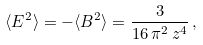<formula> <loc_0><loc_0><loc_500><loc_500>\langle { E } ^ { 2 } \rangle = - \langle { B } ^ { 2 } \rangle = \frac { 3 } { 1 6 \, \pi ^ { 2 } \, z ^ { 4 } } \, ,</formula> 